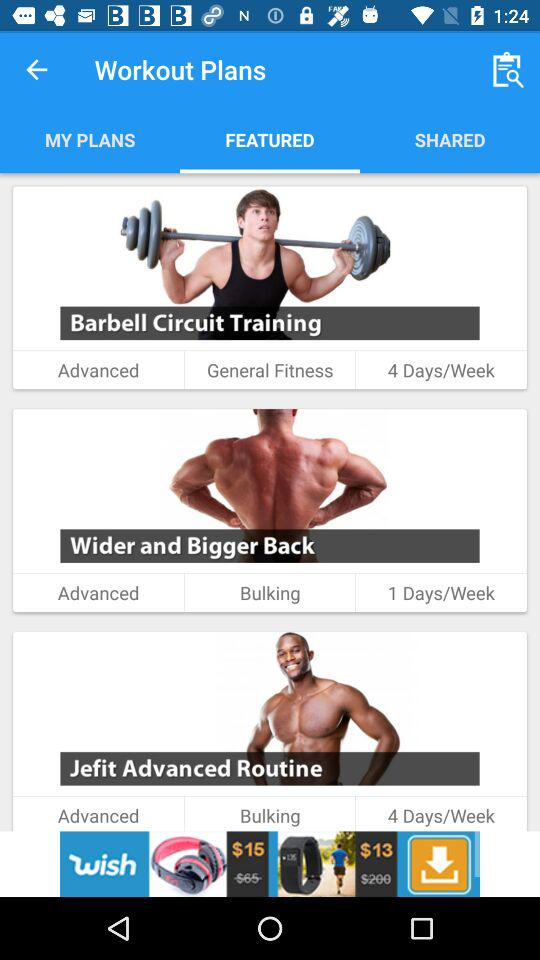What type of fitness is emphasized by the "Wider and Bigger Back" workout plan? The "Wider and Bigger Back" workout plan emphasizes bulking up. 